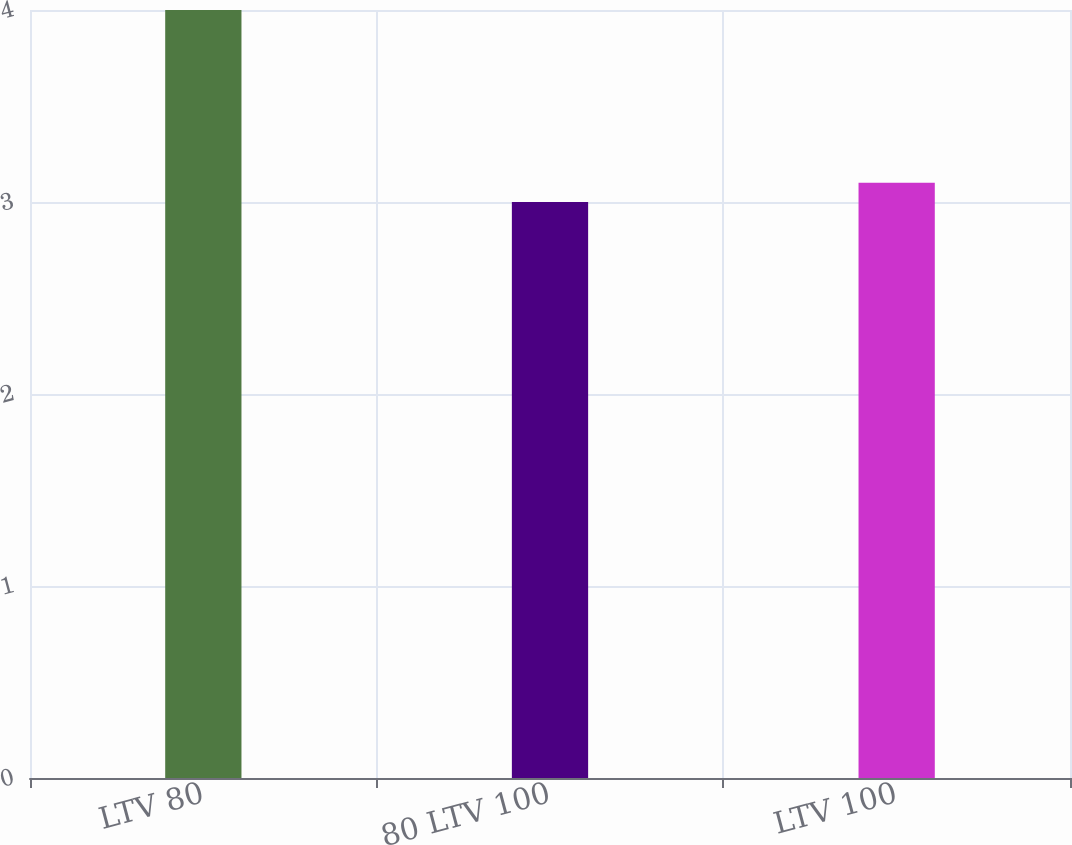Convert chart. <chart><loc_0><loc_0><loc_500><loc_500><bar_chart><fcel>LTV 80<fcel>80 LTV 100<fcel>LTV 100<nl><fcel>4<fcel>3<fcel>3.1<nl></chart> 